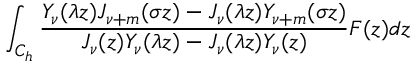Convert formula to latex. <formula><loc_0><loc_0><loc_500><loc_500>\int _ { C _ { h } } { \frac { Y _ { \nu } ( \lambda z ) J _ { \nu + m } ( \sigma z ) - J _ { \nu } ( \lambda z ) Y _ { \nu + m } ( \sigma z ) } { J _ { \nu } ( z ) Y _ { \nu } ( \lambda z ) - J _ { \nu } ( \lambda z ) Y _ { \nu } ( z ) } F ( z ) d z }</formula> 